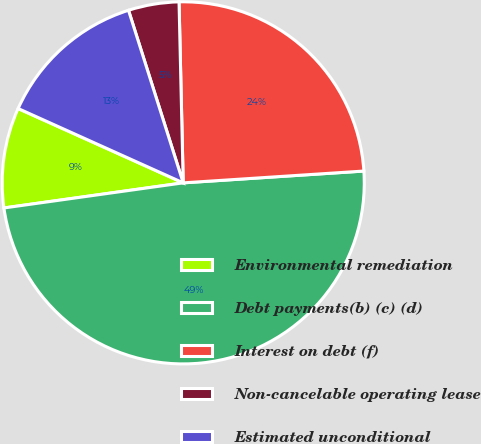Convert chart to OTSL. <chart><loc_0><loc_0><loc_500><loc_500><pie_chart><fcel>Environmental remediation<fcel>Debt payments(b) (c) (d)<fcel>Interest on debt (f)<fcel>Non-cancelable operating lease<fcel>Estimated unconditional<nl><fcel>8.95%<fcel>48.83%<fcel>24.33%<fcel>4.52%<fcel>13.38%<nl></chart> 